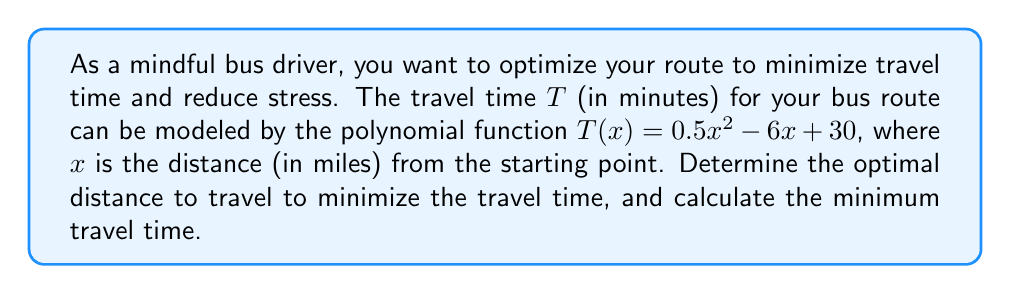Help me with this question. To solve this problem, we'll follow these steps:

1) The travel time function is a quadratic polynomial: $T(x) = 0.5x^2 - 6x + 30$

2) To find the minimum point of a quadratic function, we need to find the vertex. The x-coordinate of the vertex represents the optimal distance, and the y-coordinate represents the minimum travel time.

3) For a quadratic function in the form $f(x) = ax^2 + bx + c$, the x-coordinate of the vertex is given by $x = -\frac{b}{2a}$

4) In our case, $a = 0.5$, $b = -6$, and $c = 30$

5) Calculating the x-coordinate of the vertex:

   $x = -\frac{b}{2a} = -\frac{-6}{2(0.5)} = \frac{6}{1} = 6$

6) This means the optimal distance to travel is 6 miles.

7) To find the minimum travel time, we substitute $x = 6$ into the original function:

   $T(6) = 0.5(6)^2 - 6(6) + 30$
         $= 0.5(36) - 36 + 30$
         $= 18 - 36 + 30$
         $= 12$

Therefore, the minimum travel time is 12 minutes.
Answer: The optimal distance to travel is 6 miles, and the minimum travel time is 12 minutes. 